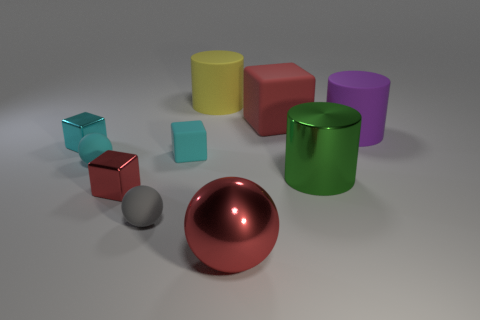Subtract all cyan cubes. How many were subtracted if there are1cyan cubes left? 1 Subtract all cylinders. How many objects are left? 7 Add 8 large balls. How many large balls exist? 9 Subtract 1 cyan cubes. How many objects are left? 9 Subtract all red matte blocks. Subtract all small green matte cylinders. How many objects are left? 9 Add 5 large metal cylinders. How many large metal cylinders are left? 6 